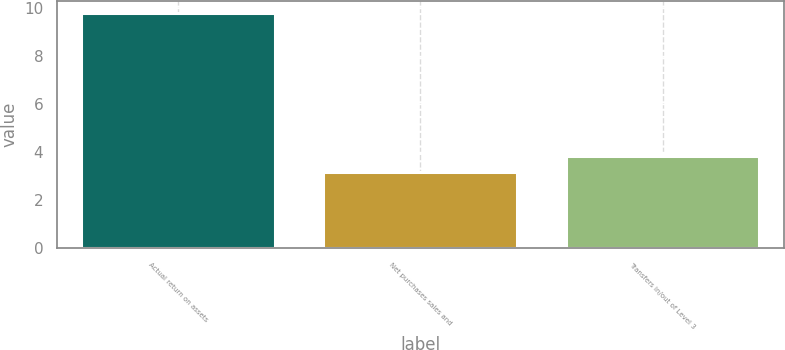Convert chart. <chart><loc_0><loc_0><loc_500><loc_500><bar_chart><fcel>Actual return on assets<fcel>Net purchases sales and<fcel>Transfers in/out of Level 3<nl><fcel>9.8<fcel>3.2<fcel>3.86<nl></chart> 